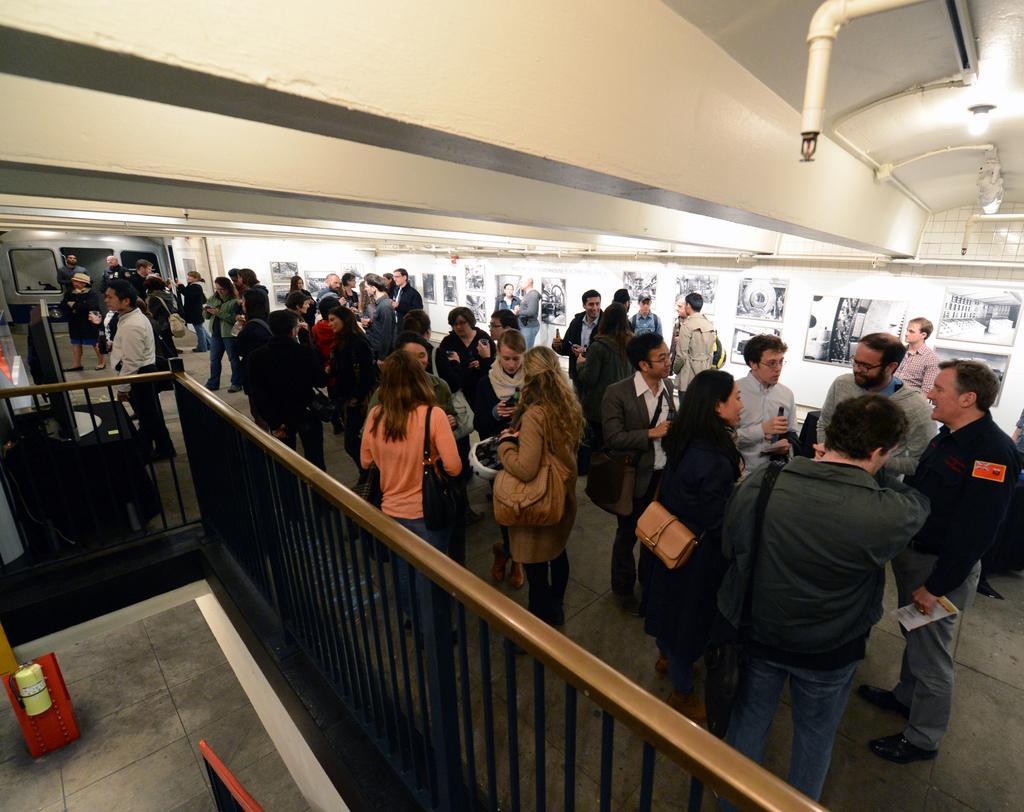In one or two sentences, can you explain what this image depicts? In this image there are people, lights, pipes, pictures, railing, monitor, table and objects. On the table there is a monitor. Pictures are on the wall. Among them few people wore bags and holding objects.   